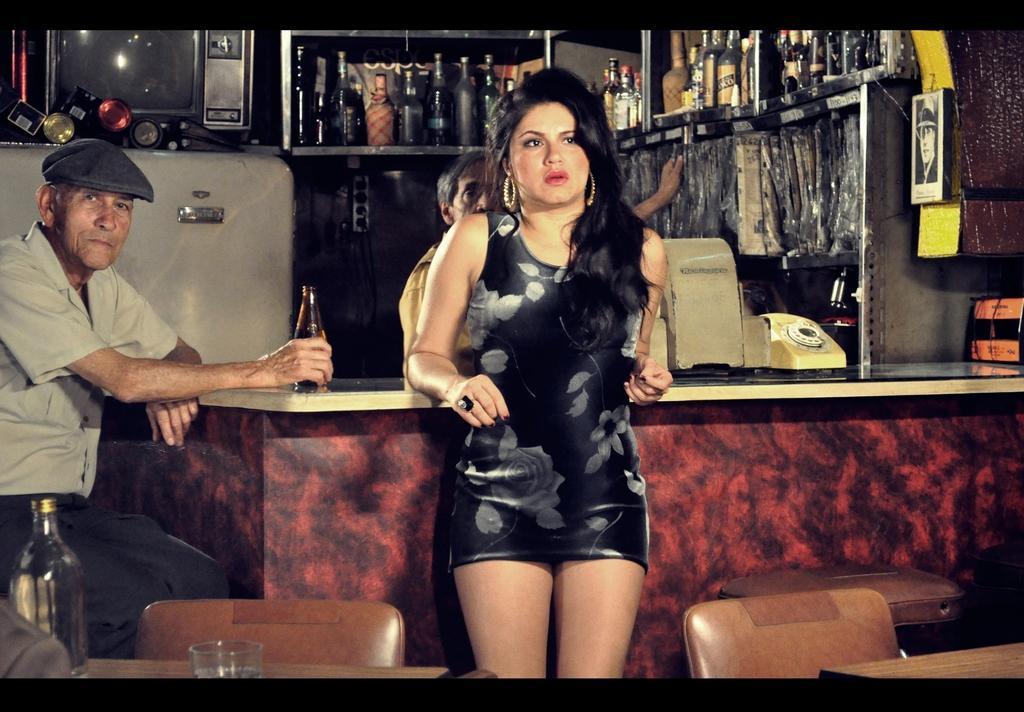Could you give a brief overview of what you see in this image? In the center of the image we can see one woman is standing and she is in black color costume. At the bottom of the image, we can see tables, chairs, one glass, bottle, ash color object, in stool and a few other objects. On the left side of the image, we can see one person is sitting and he is smiling. And we can see he is holding a bottle and he is wearing a hat. In the background there is a wall, fridge, photo frame, table, landline phone, monitor, racks, bottles, one person is standing and a few other objects. 